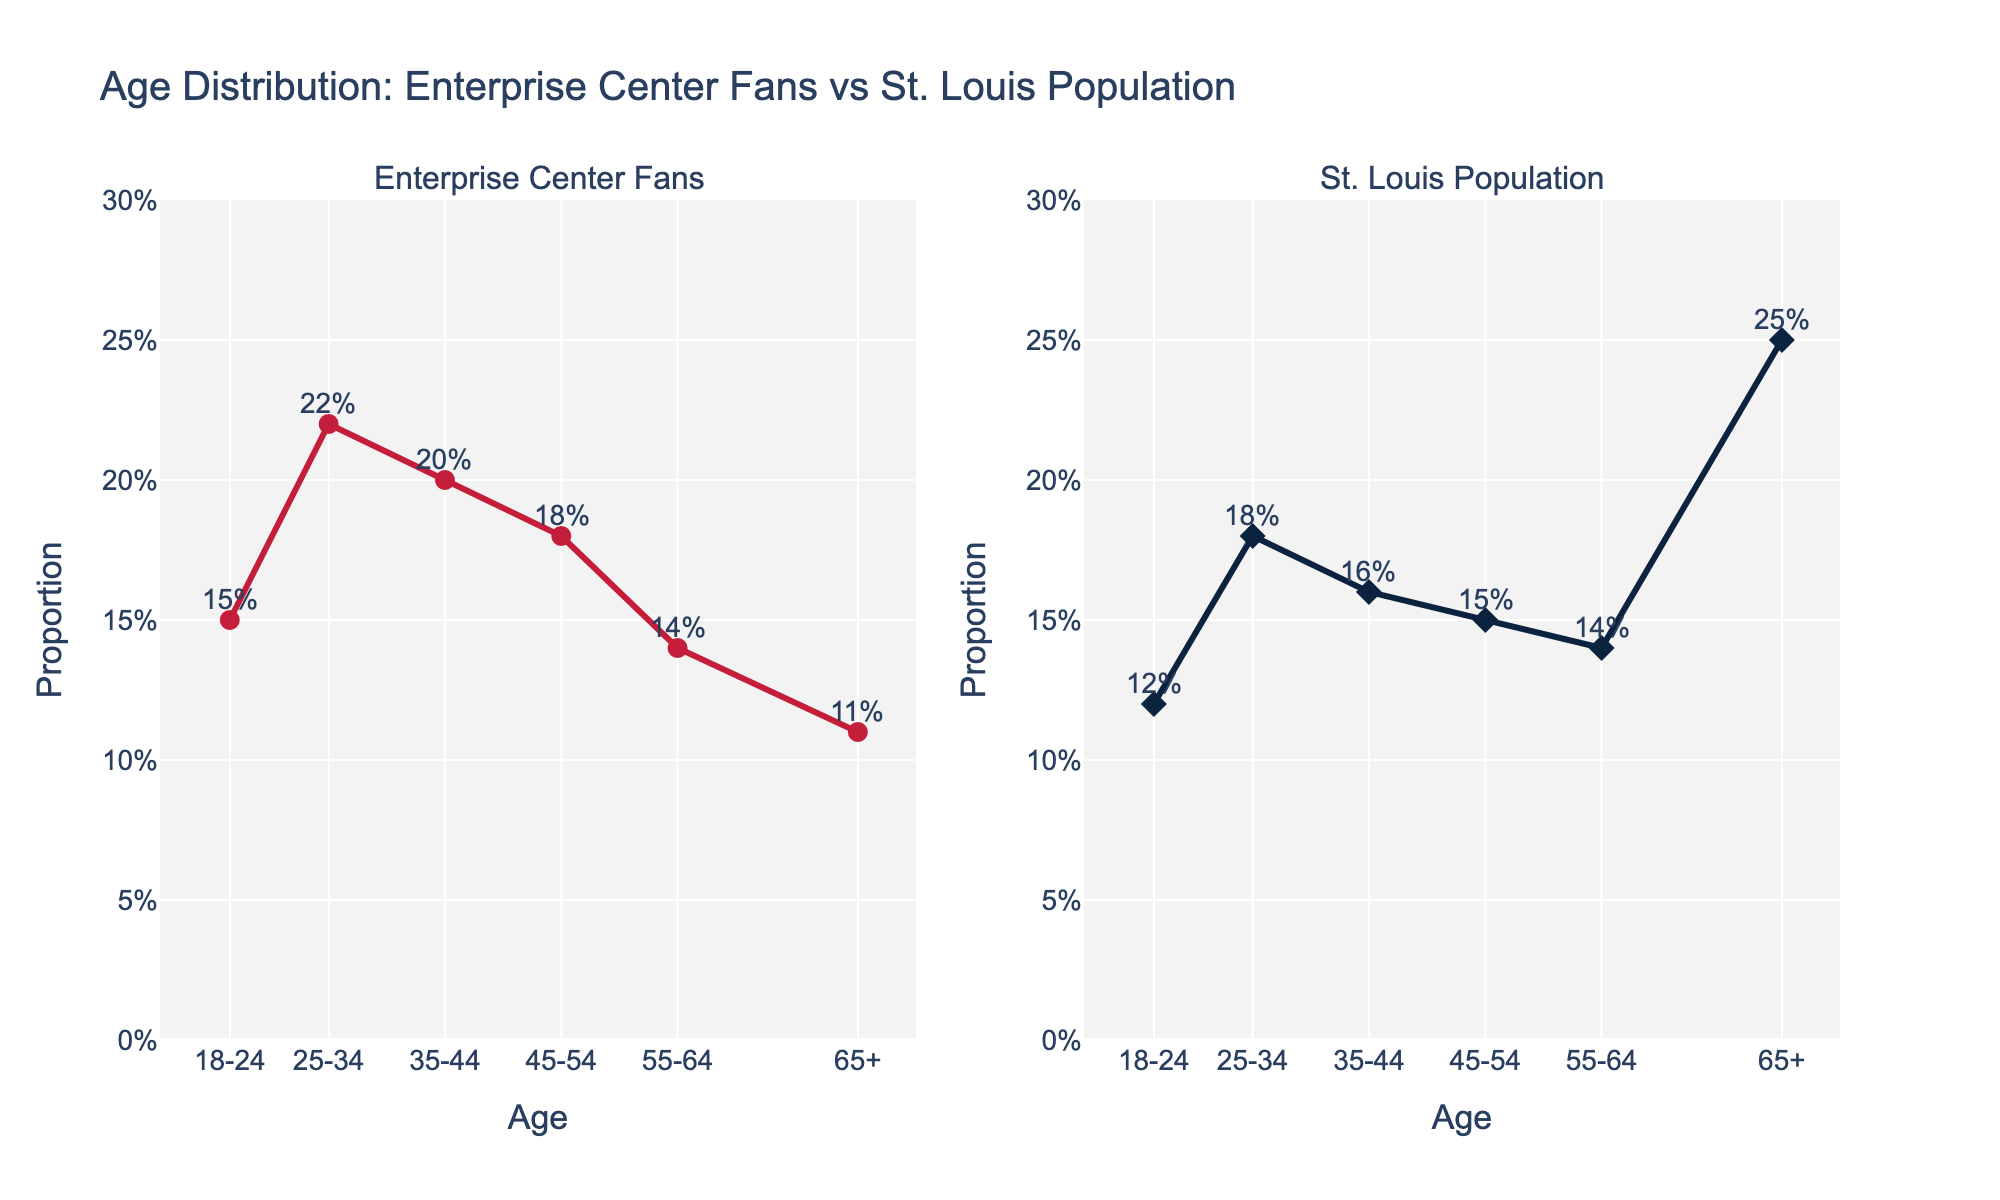What is the title of the figure? The title of the figure is located at the top, which describes the content of the subplots.
Answer: Age Distribution: Enterprise Center Fans vs St. Louis Population Which age group has the highest proportion of fans attending games at the Enterprise Center? By comparing the heights of the lines on the left subplot, the highest point corresponds to the 25-34 age group.
Answer: 25-34 How many age groups are represented in the figure? By counting the unique age groups on the x-axis, we can determine there are six different groups.
Answer: 6 What is the proportion of the 18-24 age group in the St. Louis population? Locate the point corresponding to the 18-24 age group on the right subplot, and read the percentage label next to the point.
Answer: 12% Compare the ages 35-44 and 45-54 for Enterprise Center fans. Which age group has a higher proportion? By observing the left subplot, the point for 35-44 is higher than the point for 45-54, indicating a higher proportion for 35-44.
Answer: 35-44 What is the difference in proportions between the 25-34 age group of Enterprise Center fans and the St. Louis population? Locate the corresponding points for the 25-34 age group in both subplots, note the values (0.22 for fans, 0.18 for population), and subtract the population proportion from the fans proportion (0.22 - 0.18).
Answer: 0.04 Which age group shows a noticeable difference between Enterprise Center fans and the St. Louis population? Comparing both subplots, the 65+ age group shows the largest disparity, with a high proportion in the overall population but much lower among fans.
Answer: 65+ What is the range of proportions for Enterprise Center fans across all age groups? Identify the highest and lowest proportions in the left subplot (0.22 for 25-34 and 0.11 for 65+), and subtract the lowest from the highest (0.22 - 0.11).
Answer: 0.11 Is there any age group where the proportion is exactly the same for both Enterprise Center fans and the St. Louis population? Observe if any points in both subplots align perfectly, indicating the same proportion. The group 55-64 has the same proportion of 0.14 in both subplots.
Answer: 55-64 For the 45-54 age group, which subplot has the higher proportion? By looking at the 45-54 age group in both subplots, the left subplot (Enterprise Center fans) has a higher point than the right subplot (St. Louis population).
Answer: Enterprise Center fans 